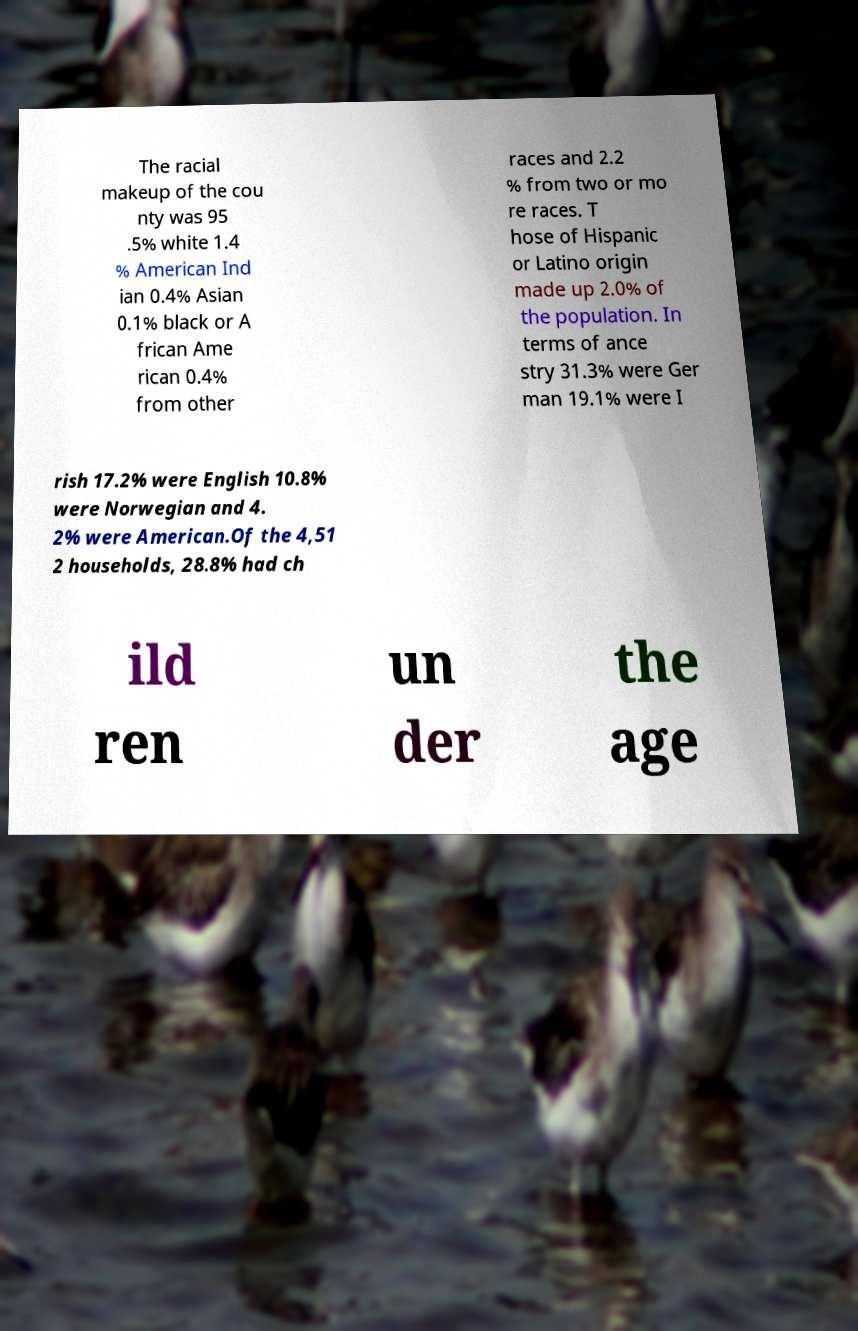Please read and relay the text visible in this image. What does it say? The racial makeup of the cou nty was 95 .5% white 1.4 % American Ind ian 0.4% Asian 0.1% black or A frican Ame rican 0.4% from other races and 2.2 % from two or mo re races. T hose of Hispanic or Latino origin made up 2.0% of the population. In terms of ance stry 31.3% were Ger man 19.1% were I rish 17.2% were English 10.8% were Norwegian and 4. 2% were American.Of the 4,51 2 households, 28.8% had ch ild ren un der the age 